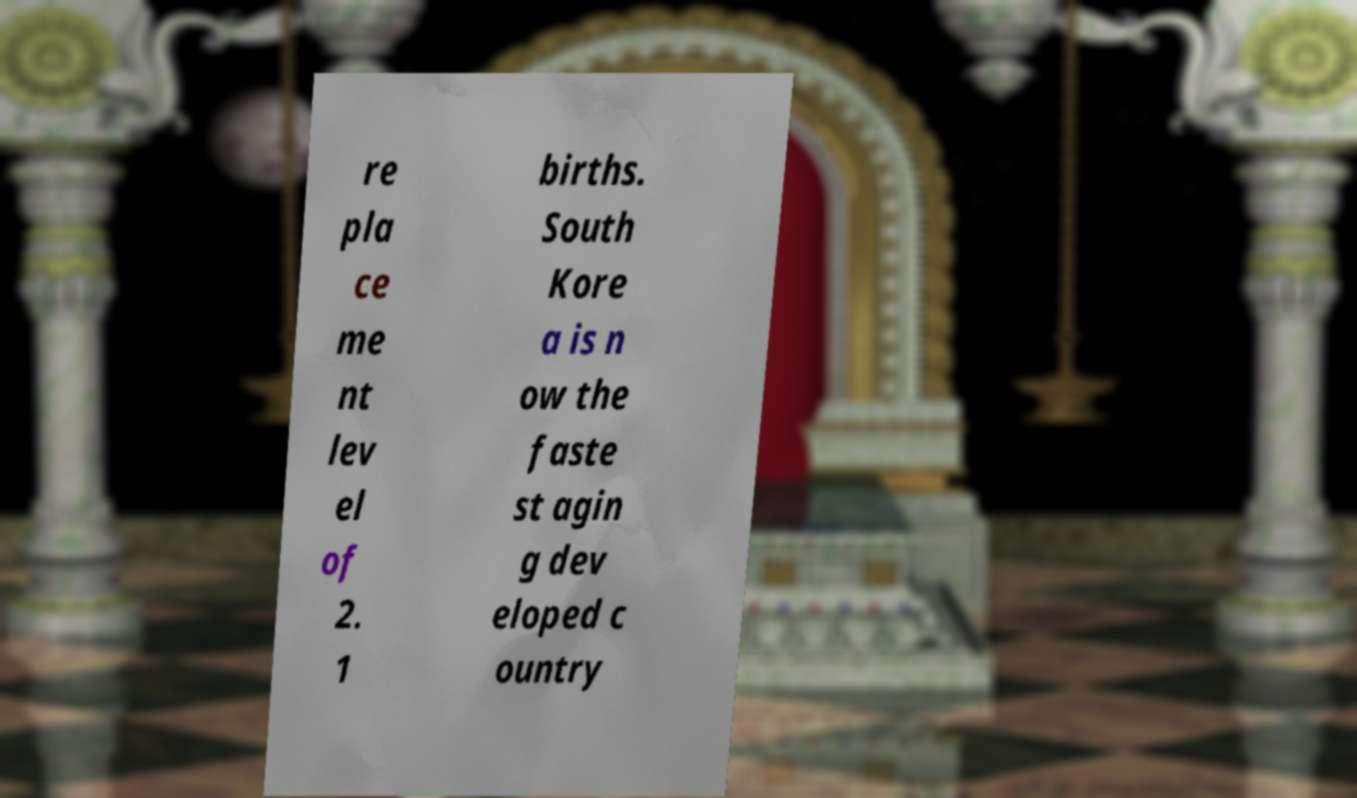Please read and relay the text visible in this image. What does it say? re pla ce me nt lev el of 2. 1 births. South Kore a is n ow the faste st agin g dev eloped c ountry 